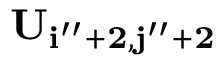<formula> <loc_0><loc_0><loc_500><loc_500>U _ { i ^ { \prime \prime } + 2 , j ^ { \prime \prime } + 2 }</formula> 